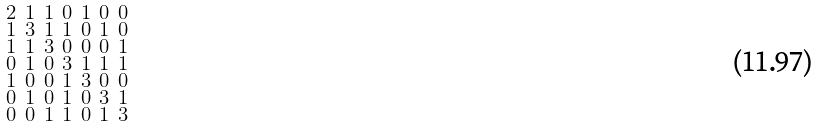<formula> <loc_0><loc_0><loc_500><loc_500>\begin{smallmatrix} 2 & 1 & 1 & 0 & 1 & 0 & 0 \\ 1 & 3 & 1 & 1 & 0 & 1 & 0 \\ 1 & 1 & 3 & 0 & 0 & 0 & 1 \\ 0 & 1 & 0 & 3 & 1 & 1 & 1 \\ 1 & 0 & 0 & 1 & 3 & 0 & 0 \\ 0 & 1 & 0 & 1 & 0 & 3 & 1 \\ 0 & 0 & 1 & 1 & 0 & 1 & 3 \end{smallmatrix}</formula> 